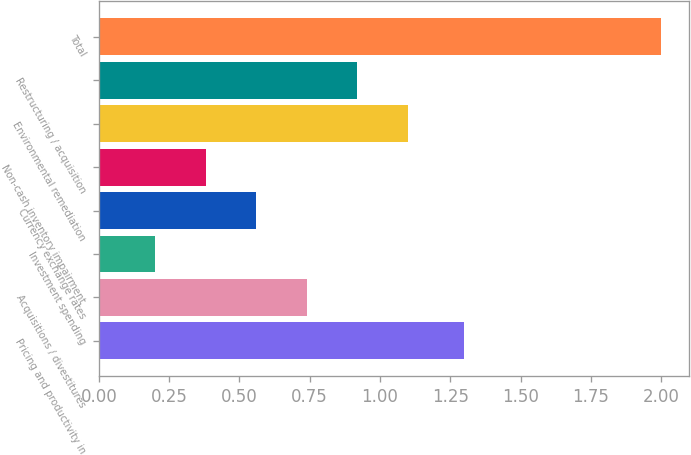Convert chart to OTSL. <chart><loc_0><loc_0><loc_500><loc_500><bar_chart><fcel>Pricing and productivity in<fcel>Acquisitions / divestitures<fcel>Investment spending<fcel>Currency exchange rates<fcel>Non-cash inventory impairment<fcel>Environmental remediation<fcel>Restructuring / acquisition<fcel>Total<nl><fcel>1.3<fcel>0.74<fcel>0.2<fcel>0.56<fcel>0.38<fcel>1.1<fcel>0.92<fcel>2<nl></chart> 